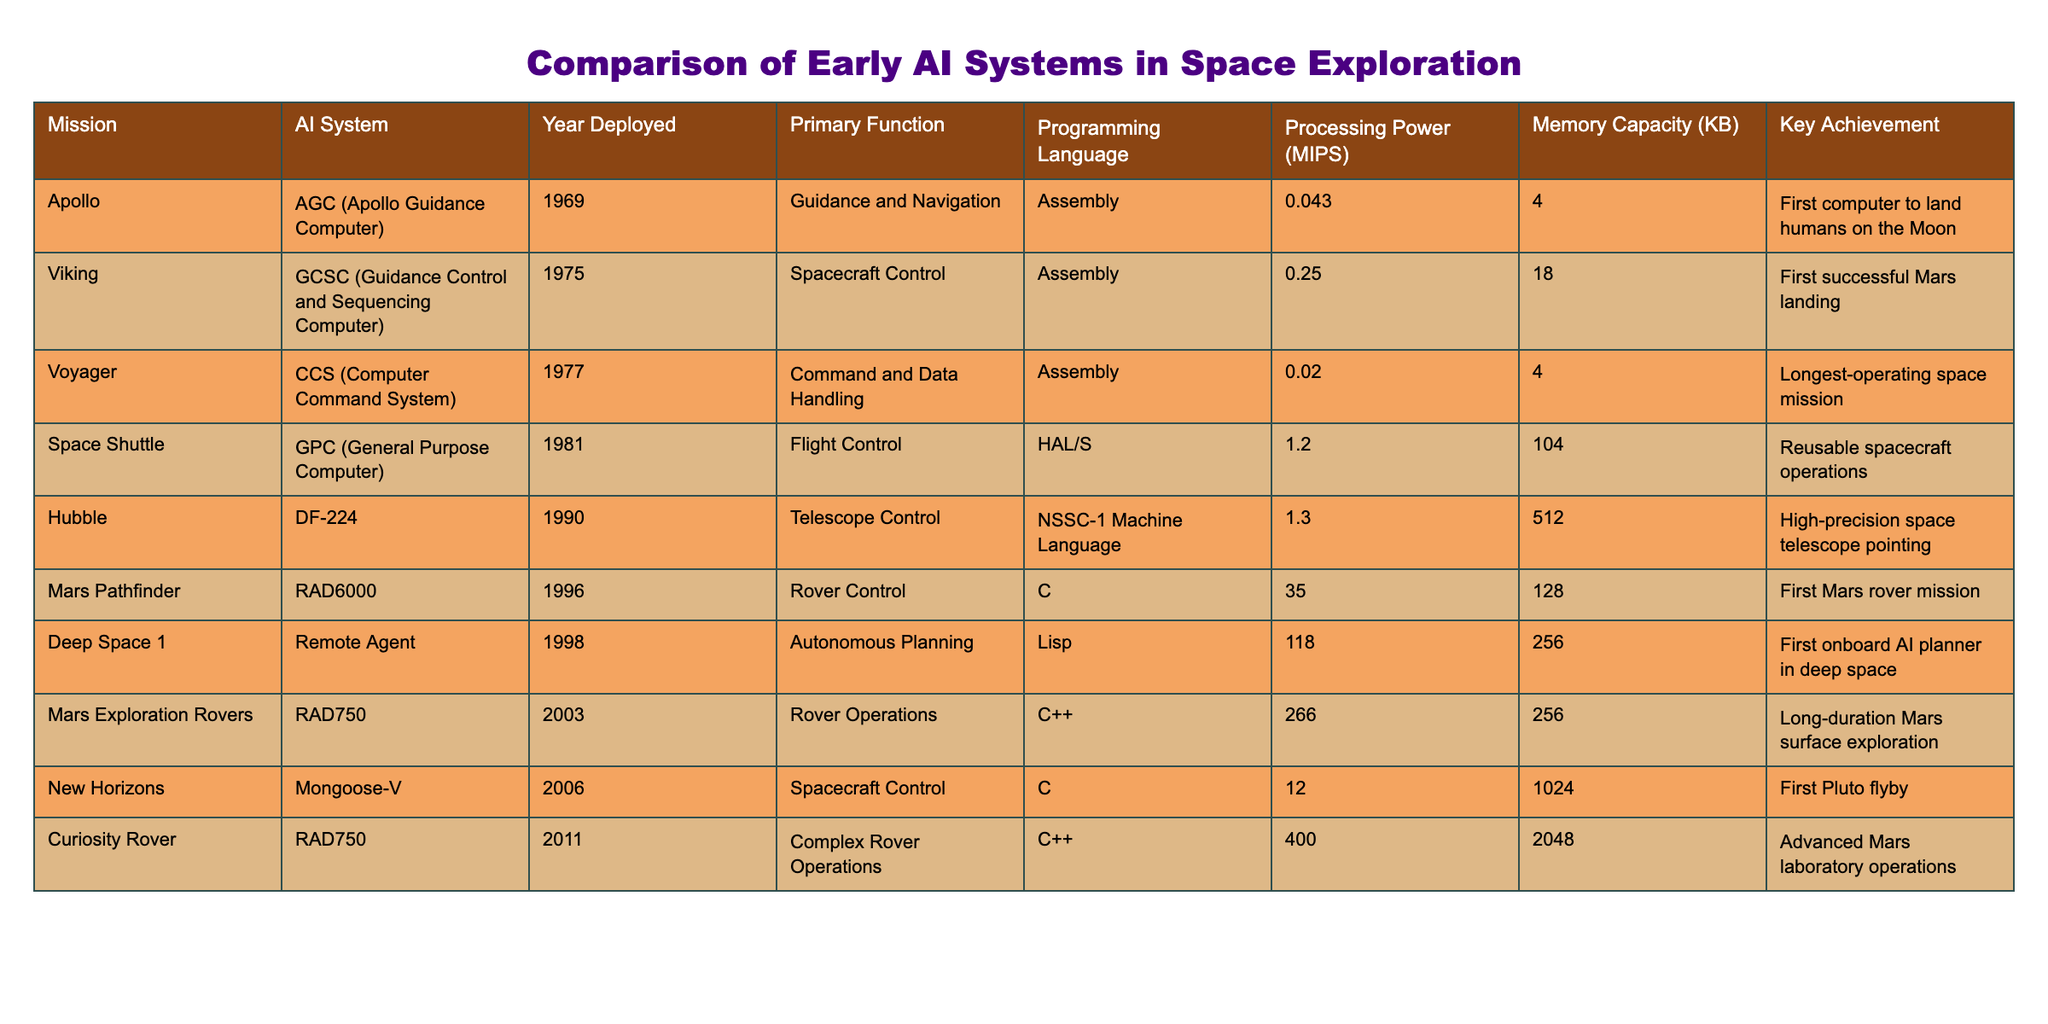What was the primary function of the AGC used in the Apollo mission? The AGC was specifically designed for Guidance and Navigation, which can be directly found in the table under the corresponding mission and AI system.
Answer: Guidance and Navigation Which AI system had the highest processing power, and what was its value in MIPS? By reviewing the Processing Power column, the AI system RAD750 used in Mars Exploration Rovers has the highest value of 266 MIPS.
Answer: RAD750, 266 MIPS Did the first successful Mars landing utilize an AI system? The table shows that the GCSC used in the Viking mission, which achieved the first successful Mars landing, is indeed an AI system.
Answer: Yes What is the average memory capacity of the AI systems used in the table? To find the average memory capacity, we add up all the values in the Memory Capacity column (4 + 18 + 4 + 104 + 512 + 128 + 256 + 1024 + 2048 = 3098) and divide by the number of entries (9). The average memory capacity is 3098 / 9 ≈ 344.22 KB.
Answer: 344.22 KB Which two AI systems were deployed in the same decade, and what were their primary functions? Looking at the Year Deployed column, both the RAD6000 (Rover Control) and Remote Agent (Autonomous Planning) were deployed in the 1990s.
Answer: RAD6000: Rover Control, Remote Agent: Autonomous Planning Was there a notable achievement linked to the Curiosity Rover? The table indicates that the Curiosity Rover was recognized for advanced Mars laboratory operations, thereby affirming its notable achievement.
Answer: Yes What is the difference in processing power between the lowest and highest AI systems? The lowest processing power is 0.02 MIPS (CCS) and the highest is 266 MIPS (RAD750). The difference is calculated by subtracting: 266 - 0.02 = 265.98 MIPS.
Answer: 265.98 MIPS Which AI systems were programmed in C++ and what were their functions? By examining the Programming Language column, the RAD750 and Curiosity Rover systems were both programmed in C++, with functions of Rover Operations and Complex Rover Operations, respectively.
Answer: RAD750: Rover Operations, Curiosity Rover: Complex Rover Operations Which mission had the earliest deployment year and what was its key achievement? The Apollo mission had the earliest deployment year of 1969, and its key achievement was being the first computer to land humans on the Moon.
Answer: Apollo, First computer to land humans on the Moon 